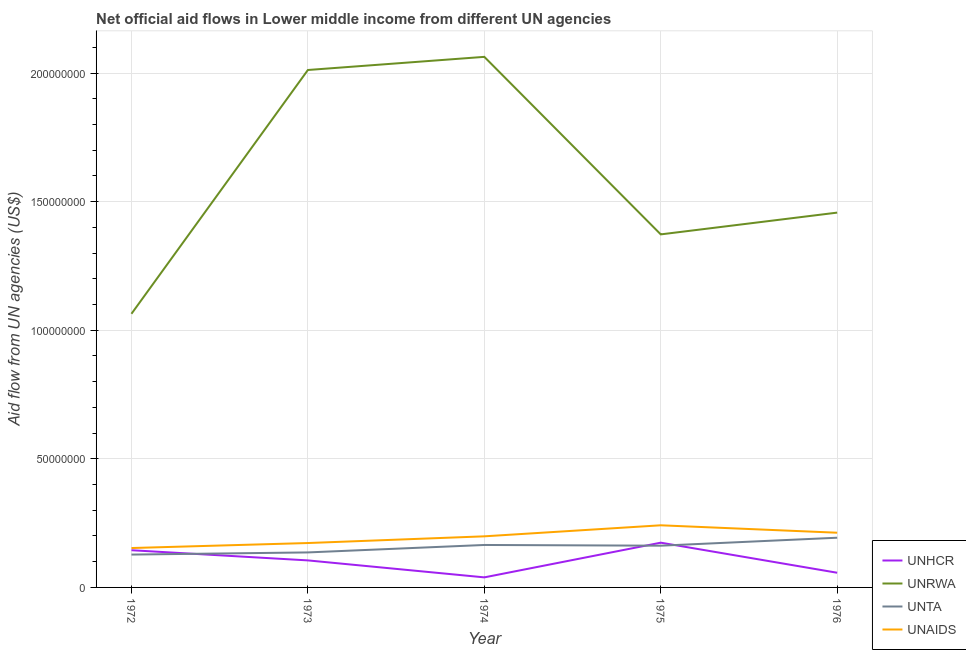How many different coloured lines are there?
Keep it short and to the point. 4. Is the number of lines equal to the number of legend labels?
Give a very brief answer. Yes. What is the amount of aid given by unta in 1973?
Your answer should be very brief. 1.36e+07. Across all years, what is the maximum amount of aid given by unaids?
Keep it short and to the point. 2.42e+07. Across all years, what is the minimum amount of aid given by unrwa?
Ensure brevity in your answer.  1.06e+08. In which year was the amount of aid given by unaids maximum?
Your response must be concise. 1975. In which year was the amount of aid given by unrwa minimum?
Your answer should be very brief. 1972. What is the total amount of aid given by unhcr in the graph?
Offer a very short reply. 5.20e+07. What is the difference between the amount of aid given by unta in 1972 and that in 1974?
Your response must be concise. -3.74e+06. What is the difference between the amount of aid given by unaids in 1973 and the amount of aid given by unta in 1974?
Give a very brief answer. 7.50e+05. What is the average amount of aid given by unaids per year?
Provide a short and direct response. 1.96e+07. In the year 1975, what is the difference between the amount of aid given by unta and amount of aid given by unrwa?
Give a very brief answer. -1.21e+08. In how many years, is the amount of aid given by unaids greater than 130000000 US$?
Your response must be concise. 0. What is the ratio of the amount of aid given by unta in 1975 to that in 1976?
Your response must be concise. 0.84. Is the amount of aid given by unta in 1972 less than that in 1974?
Make the answer very short. Yes. What is the difference between the highest and the second highest amount of aid given by unrwa?
Provide a short and direct response. 5.11e+06. What is the difference between the highest and the lowest amount of aid given by unrwa?
Keep it short and to the point. 9.99e+07. Is it the case that in every year, the sum of the amount of aid given by unrwa and amount of aid given by unaids is greater than the sum of amount of aid given by unta and amount of aid given by unhcr?
Keep it short and to the point. Yes. Is the amount of aid given by unrwa strictly greater than the amount of aid given by unhcr over the years?
Give a very brief answer. Yes. How many lines are there?
Your answer should be very brief. 4. Does the graph contain grids?
Ensure brevity in your answer.  Yes. Where does the legend appear in the graph?
Offer a very short reply. Bottom right. How are the legend labels stacked?
Provide a succinct answer. Vertical. What is the title of the graph?
Offer a very short reply. Net official aid flows in Lower middle income from different UN agencies. Does "Third 20% of population" appear as one of the legend labels in the graph?
Your response must be concise. No. What is the label or title of the X-axis?
Keep it short and to the point. Year. What is the label or title of the Y-axis?
Keep it short and to the point. Aid flow from UN agencies (US$). What is the Aid flow from UN agencies (US$) in UNHCR in 1972?
Your response must be concise. 1.45e+07. What is the Aid flow from UN agencies (US$) of UNRWA in 1972?
Offer a terse response. 1.06e+08. What is the Aid flow from UN agencies (US$) in UNTA in 1972?
Your answer should be compact. 1.28e+07. What is the Aid flow from UN agencies (US$) in UNAIDS in 1972?
Provide a short and direct response. 1.53e+07. What is the Aid flow from UN agencies (US$) in UNHCR in 1973?
Keep it short and to the point. 1.05e+07. What is the Aid flow from UN agencies (US$) in UNRWA in 1973?
Offer a very short reply. 2.01e+08. What is the Aid flow from UN agencies (US$) of UNTA in 1973?
Give a very brief answer. 1.36e+07. What is the Aid flow from UN agencies (US$) in UNAIDS in 1973?
Keep it short and to the point. 1.73e+07. What is the Aid flow from UN agencies (US$) of UNHCR in 1974?
Your answer should be compact. 3.91e+06. What is the Aid flow from UN agencies (US$) in UNRWA in 1974?
Give a very brief answer. 2.06e+08. What is the Aid flow from UN agencies (US$) in UNTA in 1974?
Ensure brevity in your answer.  1.65e+07. What is the Aid flow from UN agencies (US$) in UNAIDS in 1974?
Your response must be concise. 1.99e+07. What is the Aid flow from UN agencies (US$) of UNHCR in 1975?
Make the answer very short. 1.74e+07. What is the Aid flow from UN agencies (US$) of UNRWA in 1975?
Offer a very short reply. 1.37e+08. What is the Aid flow from UN agencies (US$) in UNTA in 1975?
Offer a terse response. 1.62e+07. What is the Aid flow from UN agencies (US$) of UNAIDS in 1975?
Give a very brief answer. 2.42e+07. What is the Aid flow from UN agencies (US$) of UNHCR in 1976?
Offer a very short reply. 5.71e+06. What is the Aid flow from UN agencies (US$) in UNRWA in 1976?
Offer a very short reply. 1.46e+08. What is the Aid flow from UN agencies (US$) in UNTA in 1976?
Make the answer very short. 1.93e+07. What is the Aid flow from UN agencies (US$) in UNAIDS in 1976?
Ensure brevity in your answer.  2.13e+07. Across all years, what is the maximum Aid flow from UN agencies (US$) of UNHCR?
Provide a short and direct response. 1.74e+07. Across all years, what is the maximum Aid flow from UN agencies (US$) of UNRWA?
Provide a succinct answer. 2.06e+08. Across all years, what is the maximum Aid flow from UN agencies (US$) of UNTA?
Provide a succinct answer. 1.93e+07. Across all years, what is the maximum Aid flow from UN agencies (US$) of UNAIDS?
Provide a short and direct response. 2.42e+07. Across all years, what is the minimum Aid flow from UN agencies (US$) of UNHCR?
Ensure brevity in your answer.  3.91e+06. Across all years, what is the minimum Aid flow from UN agencies (US$) in UNRWA?
Provide a short and direct response. 1.06e+08. Across all years, what is the minimum Aid flow from UN agencies (US$) in UNTA?
Make the answer very short. 1.28e+07. Across all years, what is the minimum Aid flow from UN agencies (US$) in UNAIDS?
Offer a terse response. 1.53e+07. What is the total Aid flow from UN agencies (US$) in UNHCR in the graph?
Ensure brevity in your answer.  5.20e+07. What is the total Aid flow from UN agencies (US$) of UNRWA in the graph?
Your response must be concise. 7.97e+08. What is the total Aid flow from UN agencies (US$) in UNTA in the graph?
Your answer should be very brief. 7.84e+07. What is the total Aid flow from UN agencies (US$) in UNAIDS in the graph?
Make the answer very short. 9.79e+07. What is the difference between the Aid flow from UN agencies (US$) in UNHCR in 1972 and that in 1973?
Make the answer very short. 3.96e+06. What is the difference between the Aid flow from UN agencies (US$) in UNRWA in 1972 and that in 1973?
Keep it short and to the point. -9.48e+07. What is the difference between the Aid flow from UN agencies (US$) of UNTA in 1972 and that in 1973?
Give a very brief answer. -8.40e+05. What is the difference between the Aid flow from UN agencies (US$) in UNAIDS in 1972 and that in 1973?
Provide a short and direct response. -1.94e+06. What is the difference between the Aid flow from UN agencies (US$) in UNHCR in 1972 and that in 1974?
Provide a short and direct response. 1.06e+07. What is the difference between the Aid flow from UN agencies (US$) in UNRWA in 1972 and that in 1974?
Provide a short and direct response. -9.99e+07. What is the difference between the Aid flow from UN agencies (US$) in UNTA in 1972 and that in 1974?
Your answer should be compact. -3.74e+06. What is the difference between the Aid flow from UN agencies (US$) of UNAIDS in 1972 and that in 1974?
Ensure brevity in your answer.  -4.55e+06. What is the difference between the Aid flow from UN agencies (US$) in UNHCR in 1972 and that in 1975?
Give a very brief answer. -2.93e+06. What is the difference between the Aid flow from UN agencies (US$) of UNRWA in 1972 and that in 1975?
Ensure brevity in your answer.  -3.09e+07. What is the difference between the Aid flow from UN agencies (US$) in UNTA in 1972 and that in 1975?
Ensure brevity in your answer.  -3.46e+06. What is the difference between the Aid flow from UN agencies (US$) in UNAIDS in 1972 and that in 1975?
Keep it short and to the point. -8.84e+06. What is the difference between the Aid flow from UN agencies (US$) in UNHCR in 1972 and that in 1976?
Offer a very short reply. 8.76e+06. What is the difference between the Aid flow from UN agencies (US$) of UNRWA in 1972 and that in 1976?
Your response must be concise. -3.93e+07. What is the difference between the Aid flow from UN agencies (US$) in UNTA in 1972 and that in 1976?
Keep it short and to the point. -6.56e+06. What is the difference between the Aid flow from UN agencies (US$) of UNAIDS in 1972 and that in 1976?
Offer a very short reply. -5.95e+06. What is the difference between the Aid flow from UN agencies (US$) of UNHCR in 1973 and that in 1974?
Your answer should be very brief. 6.60e+06. What is the difference between the Aid flow from UN agencies (US$) of UNRWA in 1973 and that in 1974?
Give a very brief answer. -5.11e+06. What is the difference between the Aid flow from UN agencies (US$) of UNTA in 1973 and that in 1974?
Offer a very short reply. -2.90e+06. What is the difference between the Aid flow from UN agencies (US$) in UNAIDS in 1973 and that in 1974?
Your answer should be compact. -2.61e+06. What is the difference between the Aid flow from UN agencies (US$) of UNHCR in 1973 and that in 1975?
Provide a short and direct response. -6.89e+06. What is the difference between the Aid flow from UN agencies (US$) in UNRWA in 1973 and that in 1975?
Ensure brevity in your answer.  6.39e+07. What is the difference between the Aid flow from UN agencies (US$) in UNTA in 1973 and that in 1975?
Offer a terse response. -2.62e+06. What is the difference between the Aid flow from UN agencies (US$) in UNAIDS in 1973 and that in 1975?
Keep it short and to the point. -6.90e+06. What is the difference between the Aid flow from UN agencies (US$) in UNHCR in 1973 and that in 1976?
Offer a very short reply. 4.80e+06. What is the difference between the Aid flow from UN agencies (US$) of UNRWA in 1973 and that in 1976?
Provide a short and direct response. 5.55e+07. What is the difference between the Aid flow from UN agencies (US$) of UNTA in 1973 and that in 1976?
Your answer should be very brief. -5.72e+06. What is the difference between the Aid flow from UN agencies (US$) in UNAIDS in 1973 and that in 1976?
Your answer should be compact. -4.01e+06. What is the difference between the Aid flow from UN agencies (US$) in UNHCR in 1974 and that in 1975?
Provide a short and direct response. -1.35e+07. What is the difference between the Aid flow from UN agencies (US$) of UNRWA in 1974 and that in 1975?
Give a very brief answer. 6.90e+07. What is the difference between the Aid flow from UN agencies (US$) in UNAIDS in 1974 and that in 1975?
Your answer should be compact. -4.29e+06. What is the difference between the Aid flow from UN agencies (US$) of UNHCR in 1974 and that in 1976?
Keep it short and to the point. -1.80e+06. What is the difference between the Aid flow from UN agencies (US$) in UNRWA in 1974 and that in 1976?
Offer a terse response. 6.06e+07. What is the difference between the Aid flow from UN agencies (US$) in UNTA in 1974 and that in 1976?
Provide a short and direct response. -2.82e+06. What is the difference between the Aid flow from UN agencies (US$) of UNAIDS in 1974 and that in 1976?
Give a very brief answer. -1.40e+06. What is the difference between the Aid flow from UN agencies (US$) in UNHCR in 1975 and that in 1976?
Offer a terse response. 1.17e+07. What is the difference between the Aid flow from UN agencies (US$) in UNRWA in 1975 and that in 1976?
Provide a short and direct response. -8.46e+06. What is the difference between the Aid flow from UN agencies (US$) of UNTA in 1975 and that in 1976?
Give a very brief answer. -3.10e+06. What is the difference between the Aid flow from UN agencies (US$) of UNAIDS in 1975 and that in 1976?
Offer a very short reply. 2.89e+06. What is the difference between the Aid flow from UN agencies (US$) of UNHCR in 1972 and the Aid flow from UN agencies (US$) of UNRWA in 1973?
Offer a very short reply. -1.87e+08. What is the difference between the Aid flow from UN agencies (US$) in UNHCR in 1972 and the Aid flow from UN agencies (US$) in UNTA in 1973?
Your response must be concise. 8.60e+05. What is the difference between the Aid flow from UN agencies (US$) in UNHCR in 1972 and the Aid flow from UN agencies (US$) in UNAIDS in 1973?
Give a very brief answer. -2.79e+06. What is the difference between the Aid flow from UN agencies (US$) in UNRWA in 1972 and the Aid flow from UN agencies (US$) in UNTA in 1973?
Offer a very short reply. 9.28e+07. What is the difference between the Aid flow from UN agencies (US$) in UNRWA in 1972 and the Aid flow from UN agencies (US$) in UNAIDS in 1973?
Keep it short and to the point. 8.91e+07. What is the difference between the Aid flow from UN agencies (US$) in UNTA in 1972 and the Aid flow from UN agencies (US$) in UNAIDS in 1973?
Provide a short and direct response. -4.49e+06. What is the difference between the Aid flow from UN agencies (US$) in UNHCR in 1972 and the Aid flow from UN agencies (US$) in UNRWA in 1974?
Give a very brief answer. -1.92e+08. What is the difference between the Aid flow from UN agencies (US$) in UNHCR in 1972 and the Aid flow from UN agencies (US$) in UNTA in 1974?
Ensure brevity in your answer.  -2.04e+06. What is the difference between the Aid flow from UN agencies (US$) in UNHCR in 1972 and the Aid flow from UN agencies (US$) in UNAIDS in 1974?
Offer a terse response. -5.40e+06. What is the difference between the Aid flow from UN agencies (US$) in UNRWA in 1972 and the Aid flow from UN agencies (US$) in UNTA in 1974?
Your answer should be compact. 8.99e+07. What is the difference between the Aid flow from UN agencies (US$) of UNRWA in 1972 and the Aid flow from UN agencies (US$) of UNAIDS in 1974?
Your response must be concise. 8.65e+07. What is the difference between the Aid flow from UN agencies (US$) in UNTA in 1972 and the Aid flow from UN agencies (US$) in UNAIDS in 1974?
Keep it short and to the point. -7.10e+06. What is the difference between the Aid flow from UN agencies (US$) of UNHCR in 1972 and the Aid flow from UN agencies (US$) of UNRWA in 1975?
Your answer should be compact. -1.23e+08. What is the difference between the Aid flow from UN agencies (US$) in UNHCR in 1972 and the Aid flow from UN agencies (US$) in UNTA in 1975?
Provide a short and direct response. -1.76e+06. What is the difference between the Aid flow from UN agencies (US$) in UNHCR in 1972 and the Aid flow from UN agencies (US$) in UNAIDS in 1975?
Your answer should be compact. -9.69e+06. What is the difference between the Aid flow from UN agencies (US$) of UNRWA in 1972 and the Aid flow from UN agencies (US$) of UNTA in 1975?
Your answer should be very brief. 9.02e+07. What is the difference between the Aid flow from UN agencies (US$) in UNRWA in 1972 and the Aid flow from UN agencies (US$) in UNAIDS in 1975?
Your answer should be compact. 8.22e+07. What is the difference between the Aid flow from UN agencies (US$) of UNTA in 1972 and the Aid flow from UN agencies (US$) of UNAIDS in 1975?
Your answer should be very brief. -1.14e+07. What is the difference between the Aid flow from UN agencies (US$) in UNHCR in 1972 and the Aid flow from UN agencies (US$) in UNRWA in 1976?
Your response must be concise. -1.31e+08. What is the difference between the Aid flow from UN agencies (US$) of UNHCR in 1972 and the Aid flow from UN agencies (US$) of UNTA in 1976?
Provide a succinct answer. -4.86e+06. What is the difference between the Aid flow from UN agencies (US$) in UNHCR in 1972 and the Aid flow from UN agencies (US$) in UNAIDS in 1976?
Your response must be concise. -6.80e+06. What is the difference between the Aid flow from UN agencies (US$) of UNRWA in 1972 and the Aid flow from UN agencies (US$) of UNTA in 1976?
Your answer should be very brief. 8.71e+07. What is the difference between the Aid flow from UN agencies (US$) of UNRWA in 1972 and the Aid flow from UN agencies (US$) of UNAIDS in 1976?
Your answer should be compact. 8.51e+07. What is the difference between the Aid flow from UN agencies (US$) of UNTA in 1972 and the Aid flow from UN agencies (US$) of UNAIDS in 1976?
Give a very brief answer. -8.50e+06. What is the difference between the Aid flow from UN agencies (US$) in UNHCR in 1973 and the Aid flow from UN agencies (US$) in UNRWA in 1974?
Make the answer very short. -1.96e+08. What is the difference between the Aid flow from UN agencies (US$) in UNHCR in 1973 and the Aid flow from UN agencies (US$) in UNTA in 1974?
Offer a very short reply. -6.00e+06. What is the difference between the Aid flow from UN agencies (US$) in UNHCR in 1973 and the Aid flow from UN agencies (US$) in UNAIDS in 1974?
Your answer should be compact. -9.36e+06. What is the difference between the Aid flow from UN agencies (US$) of UNRWA in 1973 and the Aid flow from UN agencies (US$) of UNTA in 1974?
Make the answer very short. 1.85e+08. What is the difference between the Aid flow from UN agencies (US$) of UNRWA in 1973 and the Aid flow from UN agencies (US$) of UNAIDS in 1974?
Provide a short and direct response. 1.81e+08. What is the difference between the Aid flow from UN agencies (US$) in UNTA in 1973 and the Aid flow from UN agencies (US$) in UNAIDS in 1974?
Offer a terse response. -6.26e+06. What is the difference between the Aid flow from UN agencies (US$) of UNHCR in 1973 and the Aid flow from UN agencies (US$) of UNRWA in 1975?
Offer a terse response. -1.27e+08. What is the difference between the Aid flow from UN agencies (US$) in UNHCR in 1973 and the Aid flow from UN agencies (US$) in UNTA in 1975?
Your response must be concise. -5.72e+06. What is the difference between the Aid flow from UN agencies (US$) in UNHCR in 1973 and the Aid flow from UN agencies (US$) in UNAIDS in 1975?
Your response must be concise. -1.36e+07. What is the difference between the Aid flow from UN agencies (US$) in UNRWA in 1973 and the Aid flow from UN agencies (US$) in UNTA in 1975?
Your answer should be very brief. 1.85e+08. What is the difference between the Aid flow from UN agencies (US$) of UNRWA in 1973 and the Aid flow from UN agencies (US$) of UNAIDS in 1975?
Offer a terse response. 1.77e+08. What is the difference between the Aid flow from UN agencies (US$) in UNTA in 1973 and the Aid flow from UN agencies (US$) in UNAIDS in 1975?
Offer a very short reply. -1.06e+07. What is the difference between the Aid flow from UN agencies (US$) in UNHCR in 1973 and the Aid flow from UN agencies (US$) in UNRWA in 1976?
Offer a terse response. -1.35e+08. What is the difference between the Aid flow from UN agencies (US$) of UNHCR in 1973 and the Aid flow from UN agencies (US$) of UNTA in 1976?
Make the answer very short. -8.82e+06. What is the difference between the Aid flow from UN agencies (US$) in UNHCR in 1973 and the Aid flow from UN agencies (US$) in UNAIDS in 1976?
Make the answer very short. -1.08e+07. What is the difference between the Aid flow from UN agencies (US$) of UNRWA in 1973 and the Aid flow from UN agencies (US$) of UNTA in 1976?
Provide a succinct answer. 1.82e+08. What is the difference between the Aid flow from UN agencies (US$) of UNRWA in 1973 and the Aid flow from UN agencies (US$) of UNAIDS in 1976?
Your answer should be very brief. 1.80e+08. What is the difference between the Aid flow from UN agencies (US$) in UNTA in 1973 and the Aid flow from UN agencies (US$) in UNAIDS in 1976?
Your answer should be very brief. -7.66e+06. What is the difference between the Aid flow from UN agencies (US$) in UNHCR in 1974 and the Aid flow from UN agencies (US$) in UNRWA in 1975?
Offer a very short reply. -1.33e+08. What is the difference between the Aid flow from UN agencies (US$) of UNHCR in 1974 and the Aid flow from UN agencies (US$) of UNTA in 1975?
Your response must be concise. -1.23e+07. What is the difference between the Aid flow from UN agencies (US$) of UNHCR in 1974 and the Aid flow from UN agencies (US$) of UNAIDS in 1975?
Offer a very short reply. -2.02e+07. What is the difference between the Aid flow from UN agencies (US$) in UNRWA in 1974 and the Aid flow from UN agencies (US$) in UNTA in 1975?
Provide a succinct answer. 1.90e+08. What is the difference between the Aid flow from UN agencies (US$) in UNRWA in 1974 and the Aid flow from UN agencies (US$) in UNAIDS in 1975?
Provide a short and direct response. 1.82e+08. What is the difference between the Aid flow from UN agencies (US$) in UNTA in 1974 and the Aid flow from UN agencies (US$) in UNAIDS in 1975?
Provide a short and direct response. -7.65e+06. What is the difference between the Aid flow from UN agencies (US$) in UNHCR in 1974 and the Aid flow from UN agencies (US$) in UNRWA in 1976?
Your response must be concise. -1.42e+08. What is the difference between the Aid flow from UN agencies (US$) in UNHCR in 1974 and the Aid flow from UN agencies (US$) in UNTA in 1976?
Provide a short and direct response. -1.54e+07. What is the difference between the Aid flow from UN agencies (US$) of UNHCR in 1974 and the Aid flow from UN agencies (US$) of UNAIDS in 1976?
Make the answer very short. -1.74e+07. What is the difference between the Aid flow from UN agencies (US$) in UNRWA in 1974 and the Aid flow from UN agencies (US$) in UNTA in 1976?
Keep it short and to the point. 1.87e+08. What is the difference between the Aid flow from UN agencies (US$) of UNRWA in 1974 and the Aid flow from UN agencies (US$) of UNAIDS in 1976?
Your response must be concise. 1.85e+08. What is the difference between the Aid flow from UN agencies (US$) of UNTA in 1974 and the Aid flow from UN agencies (US$) of UNAIDS in 1976?
Offer a very short reply. -4.76e+06. What is the difference between the Aid flow from UN agencies (US$) in UNHCR in 1975 and the Aid flow from UN agencies (US$) in UNRWA in 1976?
Offer a very short reply. -1.28e+08. What is the difference between the Aid flow from UN agencies (US$) in UNHCR in 1975 and the Aid flow from UN agencies (US$) in UNTA in 1976?
Your answer should be compact. -1.93e+06. What is the difference between the Aid flow from UN agencies (US$) in UNHCR in 1975 and the Aid flow from UN agencies (US$) in UNAIDS in 1976?
Your response must be concise. -3.87e+06. What is the difference between the Aid flow from UN agencies (US$) of UNRWA in 1975 and the Aid flow from UN agencies (US$) of UNTA in 1976?
Make the answer very short. 1.18e+08. What is the difference between the Aid flow from UN agencies (US$) in UNRWA in 1975 and the Aid flow from UN agencies (US$) in UNAIDS in 1976?
Make the answer very short. 1.16e+08. What is the difference between the Aid flow from UN agencies (US$) in UNTA in 1975 and the Aid flow from UN agencies (US$) in UNAIDS in 1976?
Give a very brief answer. -5.04e+06. What is the average Aid flow from UN agencies (US$) of UNHCR per year?
Offer a very short reply. 1.04e+07. What is the average Aid flow from UN agencies (US$) in UNRWA per year?
Provide a short and direct response. 1.59e+08. What is the average Aid flow from UN agencies (US$) in UNTA per year?
Offer a terse response. 1.57e+07. What is the average Aid flow from UN agencies (US$) of UNAIDS per year?
Keep it short and to the point. 1.96e+07. In the year 1972, what is the difference between the Aid flow from UN agencies (US$) of UNHCR and Aid flow from UN agencies (US$) of UNRWA?
Your answer should be very brief. -9.19e+07. In the year 1972, what is the difference between the Aid flow from UN agencies (US$) of UNHCR and Aid flow from UN agencies (US$) of UNTA?
Offer a terse response. 1.70e+06. In the year 1972, what is the difference between the Aid flow from UN agencies (US$) of UNHCR and Aid flow from UN agencies (US$) of UNAIDS?
Your response must be concise. -8.50e+05. In the year 1972, what is the difference between the Aid flow from UN agencies (US$) of UNRWA and Aid flow from UN agencies (US$) of UNTA?
Give a very brief answer. 9.36e+07. In the year 1972, what is the difference between the Aid flow from UN agencies (US$) in UNRWA and Aid flow from UN agencies (US$) in UNAIDS?
Offer a terse response. 9.11e+07. In the year 1972, what is the difference between the Aid flow from UN agencies (US$) of UNTA and Aid flow from UN agencies (US$) of UNAIDS?
Offer a terse response. -2.55e+06. In the year 1973, what is the difference between the Aid flow from UN agencies (US$) in UNHCR and Aid flow from UN agencies (US$) in UNRWA?
Ensure brevity in your answer.  -1.91e+08. In the year 1973, what is the difference between the Aid flow from UN agencies (US$) of UNHCR and Aid flow from UN agencies (US$) of UNTA?
Ensure brevity in your answer.  -3.10e+06. In the year 1973, what is the difference between the Aid flow from UN agencies (US$) in UNHCR and Aid flow from UN agencies (US$) in UNAIDS?
Make the answer very short. -6.75e+06. In the year 1973, what is the difference between the Aid flow from UN agencies (US$) of UNRWA and Aid flow from UN agencies (US$) of UNTA?
Offer a terse response. 1.88e+08. In the year 1973, what is the difference between the Aid flow from UN agencies (US$) of UNRWA and Aid flow from UN agencies (US$) of UNAIDS?
Your response must be concise. 1.84e+08. In the year 1973, what is the difference between the Aid flow from UN agencies (US$) in UNTA and Aid flow from UN agencies (US$) in UNAIDS?
Provide a succinct answer. -3.65e+06. In the year 1974, what is the difference between the Aid flow from UN agencies (US$) in UNHCR and Aid flow from UN agencies (US$) in UNRWA?
Offer a terse response. -2.02e+08. In the year 1974, what is the difference between the Aid flow from UN agencies (US$) in UNHCR and Aid flow from UN agencies (US$) in UNTA?
Provide a short and direct response. -1.26e+07. In the year 1974, what is the difference between the Aid flow from UN agencies (US$) of UNHCR and Aid flow from UN agencies (US$) of UNAIDS?
Offer a very short reply. -1.60e+07. In the year 1974, what is the difference between the Aid flow from UN agencies (US$) in UNRWA and Aid flow from UN agencies (US$) in UNTA?
Provide a short and direct response. 1.90e+08. In the year 1974, what is the difference between the Aid flow from UN agencies (US$) in UNRWA and Aid flow from UN agencies (US$) in UNAIDS?
Offer a very short reply. 1.86e+08. In the year 1974, what is the difference between the Aid flow from UN agencies (US$) of UNTA and Aid flow from UN agencies (US$) of UNAIDS?
Your answer should be very brief. -3.36e+06. In the year 1975, what is the difference between the Aid flow from UN agencies (US$) in UNHCR and Aid flow from UN agencies (US$) in UNRWA?
Offer a very short reply. -1.20e+08. In the year 1975, what is the difference between the Aid flow from UN agencies (US$) in UNHCR and Aid flow from UN agencies (US$) in UNTA?
Your response must be concise. 1.17e+06. In the year 1975, what is the difference between the Aid flow from UN agencies (US$) of UNHCR and Aid flow from UN agencies (US$) of UNAIDS?
Your response must be concise. -6.76e+06. In the year 1975, what is the difference between the Aid flow from UN agencies (US$) in UNRWA and Aid flow from UN agencies (US$) in UNTA?
Make the answer very short. 1.21e+08. In the year 1975, what is the difference between the Aid flow from UN agencies (US$) in UNRWA and Aid flow from UN agencies (US$) in UNAIDS?
Keep it short and to the point. 1.13e+08. In the year 1975, what is the difference between the Aid flow from UN agencies (US$) of UNTA and Aid flow from UN agencies (US$) of UNAIDS?
Give a very brief answer. -7.93e+06. In the year 1976, what is the difference between the Aid flow from UN agencies (US$) in UNHCR and Aid flow from UN agencies (US$) in UNRWA?
Your answer should be very brief. -1.40e+08. In the year 1976, what is the difference between the Aid flow from UN agencies (US$) of UNHCR and Aid flow from UN agencies (US$) of UNTA?
Your answer should be very brief. -1.36e+07. In the year 1976, what is the difference between the Aid flow from UN agencies (US$) of UNHCR and Aid flow from UN agencies (US$) of UNAIDS?
Your answer should be compact. -1.56e+07. In the year 1976, what is the difference between the Aid flow from UN agencies (US$) of UNRWA and Aid flow from UN agencies (US$) of UNTA?
Offer a very short reply. 1.26e+08. In the year 1976, what is the difference between the Aid flow from UN agencies (US$) of UNRWA and Aid flow from UN agencies (US$) of UNAIDS?
Provide a succinct answer. 1.24e+08. In the year 1976, what is the difference between the Aid flow from UN agencies (US$) of UNTA and Aid flow from UN agencies (US$) of UNAIDS?
Your answer should be very brief. -1.94e+06. What is the ratio of the Aid flow from UN agencies (US$) of UNHCR in 1972 to that in 1973?
Provide a short and direct response. 1.38. What is the ratio of the Aid flow from UN agencies (US$) in UNRWA in 1972 to that in 1973?
Make the answer very short. 0.53. What is the ratio of the Aid flow from UN agencies (US$) of UNTA in 1972 to that in 1973?
Your response must be concise. 0.94. What is the ratio of the Aid flow from UN agencies (US$) of UNAIDS in 1972 to that in 1973?
Give a very brief answer. 0.89. What is the ratio of the Aid flow from UN agencies (US$) in UNHCR in 1972 to that in 1974?
Your answer should be very brief. 3.7. What is the ratio of the Aid flow from UN agencies (US$) in UNRWA in 1972 to that in 1974?
Offer a terse response. 0.52. What is the ratio of the Aid flow from UN agencies (US$) of UNTA in 1972 to that in 1974?
Keep it short and to the point. 0.77. What is the ratio of the Aid flow from UN agencies (US$) in UNAIDS in 1972 to that in 1974?
Keep it short and to the point. 0.77. What is the ratio of the Aid flow from UN agencies (US$) in UNHCR in 1972 to that in 1975?
Your answer should be very brief. 0.83. What is the ratio of the Aid flow from UN agencies (US$) of UNRWA in 1972 to that in 1975?
Keep it short and to the point. 0.78. What is the ratio of the Aid flow from UN agencies (US$) of UNTA in 1972 to that in 1975?
Make the answer very short. 0.79. What is the ratio of the Aid flow from UN agencies (US$) of UNAIDS in 1972 to that in 1975?
Ensure brevity in your answer.  0.63. What is the ratio of the Aid flow from UN agencies (US$) of UNHCR in 1972 to that in 1976?
Provide a short and direct response. 2.53. What is the ratio of the Aid flow from UN agencies (US$) of UNRWA in 1972 to that in 1976?
Give a very brief answer. 0.73. What is the ratio of the Aid flow from UN agencies (US$) in UNTA in 1972 to that in 1976?
Ensure brevity in your answer.  0.66. What is the ratio of the Aid flow from UN agencies (US$) in UNAIDS in 1972 to that in 1976?
Your response must be concise. 0.72. What is the ratio of the Aid flow from UN agencies (US$) in UNHCR in 1973 to that in 1974?
Provide a succinct answer. 2.69. What is the ratio of the Aid flow from UN agencies (US$) of UNRWA in 1973 to that in 1974?
Offer a very short reply. 0.98. What is the ratio of the Aid flow from UN agencies (US$) in UNTA in 1973 to that in 1974?
Give a very brief answer. 0.82. What is the ratio of the Aid flow from UN agencies (US$) in UNAIDS in 1973 to that in 1974?
Keep it short and to the point. 0.87. What is the ratio of the Aid flow from UN agencies (US$) in UNHCR in 1973 to that in 1975?
Ensure brevity in your answer.  0.6. What is the ratio of the Aid flow from UN agencies (US$) of UNRWA in 1973 to that in 1975?
Your response must be concise. 1.47. What is the ratio of the Aid flow from UN agencies (US$) of UNTA in 1973 to that in 1975?
Provide a succinct answer. 0.84. What is the ratio of the Aid flow from UN agencies (US$) of UNAIDS in 1973 to that in 1975?
Ensure brevity in your answer.  0.71. What is the ratio of the Aid flow from UN agencies (US$) in UNHCR in 1973 to that in 1976?
Ensure brevity in your answer.  1.84. What is the ratio of the Aid flow from UN agencies (US$) of UNRWA in 1973 to that in 1976?
Ensure brevity in your answer.  1.38. What is the ratio of the Aid flow from UN agencies (US$) of UNTA in 1973 to that in 1976?
Provide a succinct answer. 0.7. What is the ratio of the Aid flow from UN agencies (US$) in UNAIDS in 1973 to that in 1976?
Your answer should be very brief. 0.81. What is the ratio of the Aid flow from UN agencies (US$) of UNHCR in 1974 to that in 1975?
Your answer should be compact. 0.22. What is the ratio of the Aid flow from UN agencies (US$) in UNRWA in 1974 to that in 1975?
Provide a short and direct response. 1.5. What is the ratio of the Aid flow from UN agencies (US$) in UNTA in 1974 to that in 1975?
Offer a very short reply. 1.02. What is the ratio of the Aid flow from UN agencies (US$) in UNAIDS in 1974 to that in 1975?
Your answer should be compact. 0.82. What is the ratio of the Aid flow from UN agencies (US$) in UNHCR in 1974 to that in 1976?
Keep it short and to the point. 0.68. What is the ratio of the Aid flow from UN agencies (US$) in UNRWA in 1974 to that in 1976?
Your answer should be very brief. 1.42. What is the ratio of the Aid flow from UN agencies (US$) of UNTA in 1974 to that in 1976?
Offer a very short reply. 0.85. What is the ratio of the Aid flow from UN agencies (US$) in UNAIDS in 1974 to that in 1976?
Provide a succinct answer. 0.93. What is the ratio of the Aid flow from UN agencies (US$) of UNHCR in 1975 to that in 1976?
Keep it short and to the point. 3.05. What is the ratio of the Aid flow from UN agencies (US$) in UNRWA in 1975 to that in 1976?
Give a very brief answer. 0.94. What is the ratio of the Aid flow from UN agencies (US$) in UNTA in 1975 to that in 1976?
Provide a short and direct response. 0.84. What is the ratio of the Aid flow from UN agencies (US$) of UNAIDS in 1975 to that in 1976?
Keep it short and to the point. 1.14. What is the difference between the highest and the second highest Aid flow from UN agencies (US$) of UNHCR?
Your response must be concise. 2.93e+06. What is the difference between the highest and the second highest Aid flow from UN agencies (US$) of UNRWA?
Offer a very short reply. 5.11e+06. What is the difference between the highest and the second highest Aid flow from UN agencies (US$) in UNTA?
Your answer should be compact. 2.82e+06. What is the difference between the highest and the second highest Aid flow from UN agencies (US$) in UNAIDS?
Your answer should be compact. 2.89e+06. What is the difference between the highest and the lowest Aid flow from UN agencies (US$) in UNHCR?
Offer a terse response. 1.35e+07. What is the difference between the highest and the lowest Aid flow from UN agencies (US$) in UNRWA?
Keep it short and to the point. 9.99e+07. What is the difference between the highest and the lowest Aid flow from UN agencies (US$) in UNTA?
Your answer should be compact. 6.56e+06. What is the difference between the highest and the lowest Aid flow from UN agencies (US$) in UNAIDS?
Ensure brevity in your answer.  8.84e+06. 